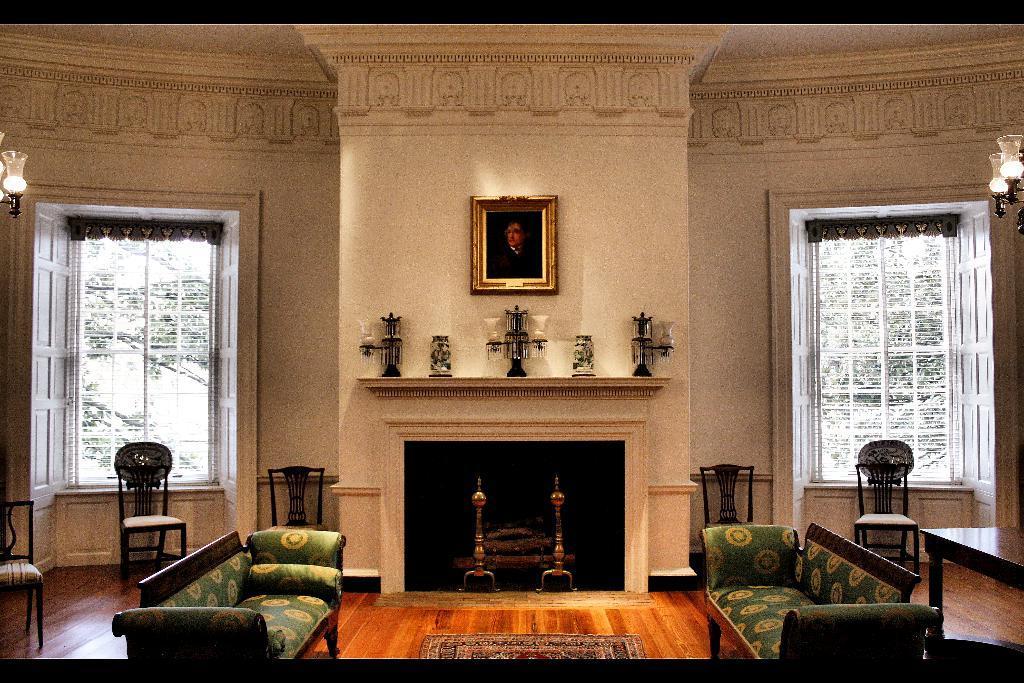In one or two sentences, can you explain what this image depicts? This is a room where sofa's are kept on the either side and windows are opened and there is a photo frame which is fixed to a wall. 